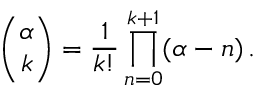Convert formula to latex. <formula><loc_0><loc_0><loc_500><loc_500>\binom { \alpha } { k } = \frac { 1 } { k ! } \prod _ { n = 0 } ^ { k + 1 } ( \alpha - n ) \, .</formula> 